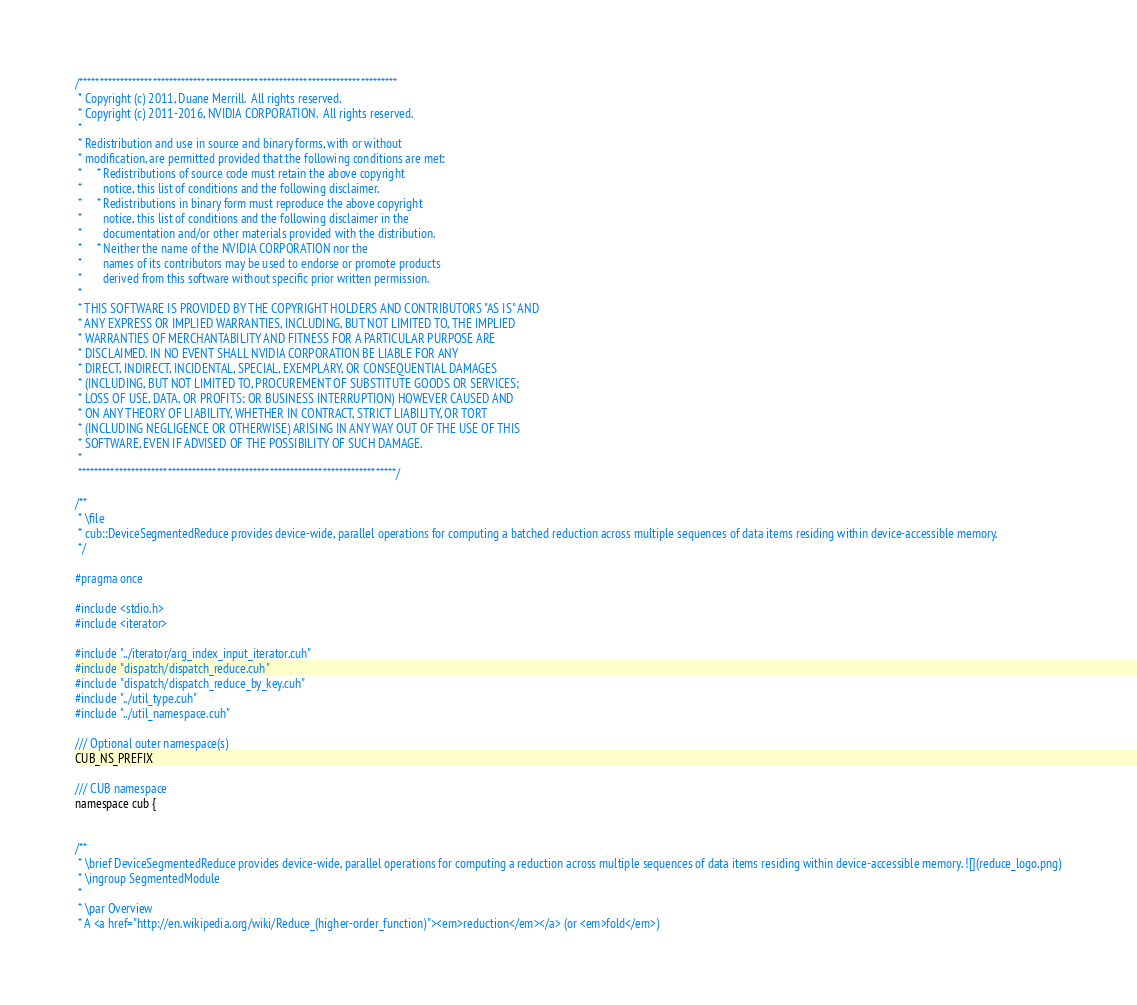Convert code to text. <code><loc_0><loc_0><loc_500><loc_500><_Cuda_>
/******************************************************************************
 * Copyright (c) 2011, Duane Merrill.  All rights reserved.
 * Copyright (c) 2011-2016, NVIDIA CORPORATION.  All rights reserved.
 *
 * Redistribution and use in source and binary forms, with or without
 * modification, are permitted provided that the following conditions are met:
 *     * Redistributions of source code must retain the above copyright
 *       notice, this list of conditions and the following disclaimer.
 *     * Redistributions in binary form must reproduce the above copyright
 *       notice, this list of conditions and the following disclaimer in the
 *       documentation and/or other materials provided with the distribution.
 *     * Neither the name of the NVIDIA CORPORATION nor the
 *       names of its contributors may be used to endorse or promote products
 *       derived from this software without specific prior written permission.
 *
 * THIS SOFTWARE IS PROVIDED BY THE COPYRIGHT HOLDERS AND CONTRIBUTORS "AS IS" AND
 * ANY EXPRESS OR IMPLIED WARRANTIES, INCLUDING, BUT NOT LIMITED TO, THE IMPLIED
 * WARRANTIES OF MERCHANTABILITY AND FITNESS FOR A PARTICULAR PURPOSE ARE
 * DISCLAIMED. IN NO EVENT SHALL NVIDIA CORPORATION BE LIABLE FOR ANY
 * DIRECT, INDIRECT, INCIDENTAL, SPECIAL, EXEMPLARY, OR CONSEQUENTIAL DAMAGES
 * (INCLUDING, BUT NOT LIMITED TO, PROCUREMENT OF SUBSTITUTE GOODS OR SERVICES;
 * LOSS OF USE, DATA, OR PROFITS; OR BUSINESS INTERRUPTION) HOWEVER CAUSED AND
 * ON ANY THEORY OF LIABILITY, WHETHER IN CONTRACT, STRICT LIABILITY, OR TORT
 * (INCLUDING NEGLIGENCE OR OTHERWISE) ARISING IN ANY WAY OUT OF THE USE OF THIS
 * SOFTWARE, EVEN IF ADVISED OF THE POSSIBILITY OF SUCH DAMAGE.
 *
 ******************************************************************************/

/**
 * \file
 * cub::DeviceSegmentedReduce provides device-wide, parallel operations for computing a batched reduction across multiple sequences of data items residing within device-accessible memory.
 */

#pragma once

#include <stdio.h>
#include <iterator>

#include "../iterator/arg_index_input_iterator.cuh"
#include "dispatch/dispatch_reduce.cuh"
#include "dispatch/dispatch_reduce_by_key.cuh"
#include "../util_type.cuh"
#include "../util_namespace.cuh"

/// Optional outer namespace(s)
CUB_NS_PREFIX

/// CUB namespace
namespace cub {


/**
 * \brief DeviceSegmentedReduce provides device-wide, parallel operations for computing a reduction across multiple sequences of data items residing within device-accessible memory. ![](reduce_logo.png)
 * \ingroup SegmentedModule
 *
 * \par Overview
 * A <a href="http://en.wikipedia.org/wiki/Reduce_(higher-order_function)"><em>reduction</em></a> (or <em>fold</em>)</code> 